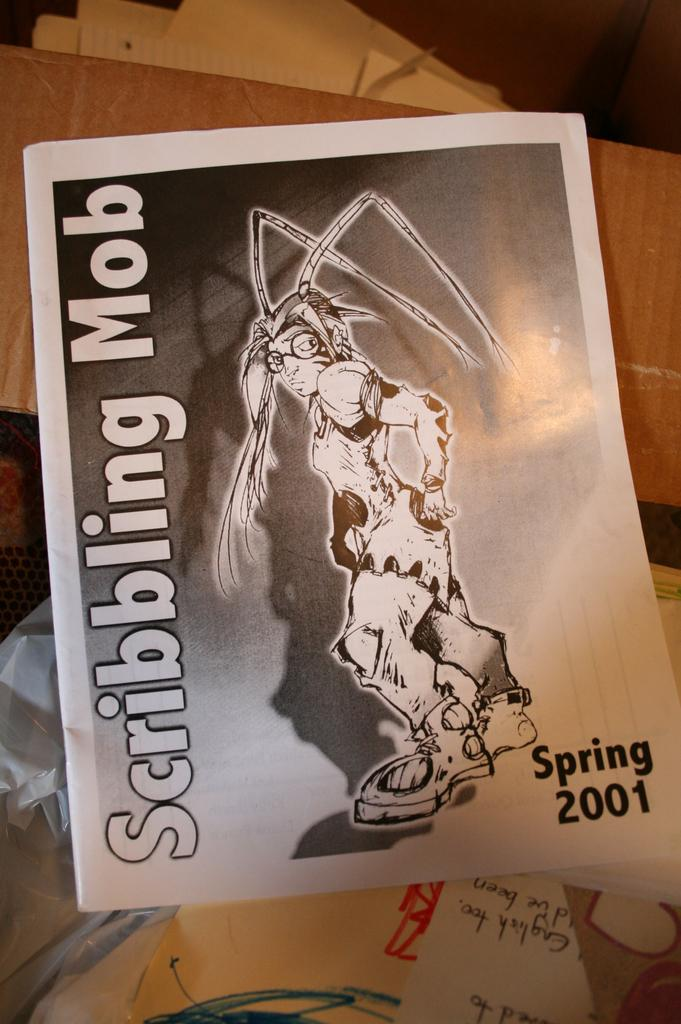What objects are on the table in the image? There are papers and a cardboard on the table. Can you describe the papers on the table? The provided facts do not give any specific details about the papers, so we cannot describe them further. What is the desire of the volcano in the image? There is no volcano present in the image, so it is not possible to determine its desires. 